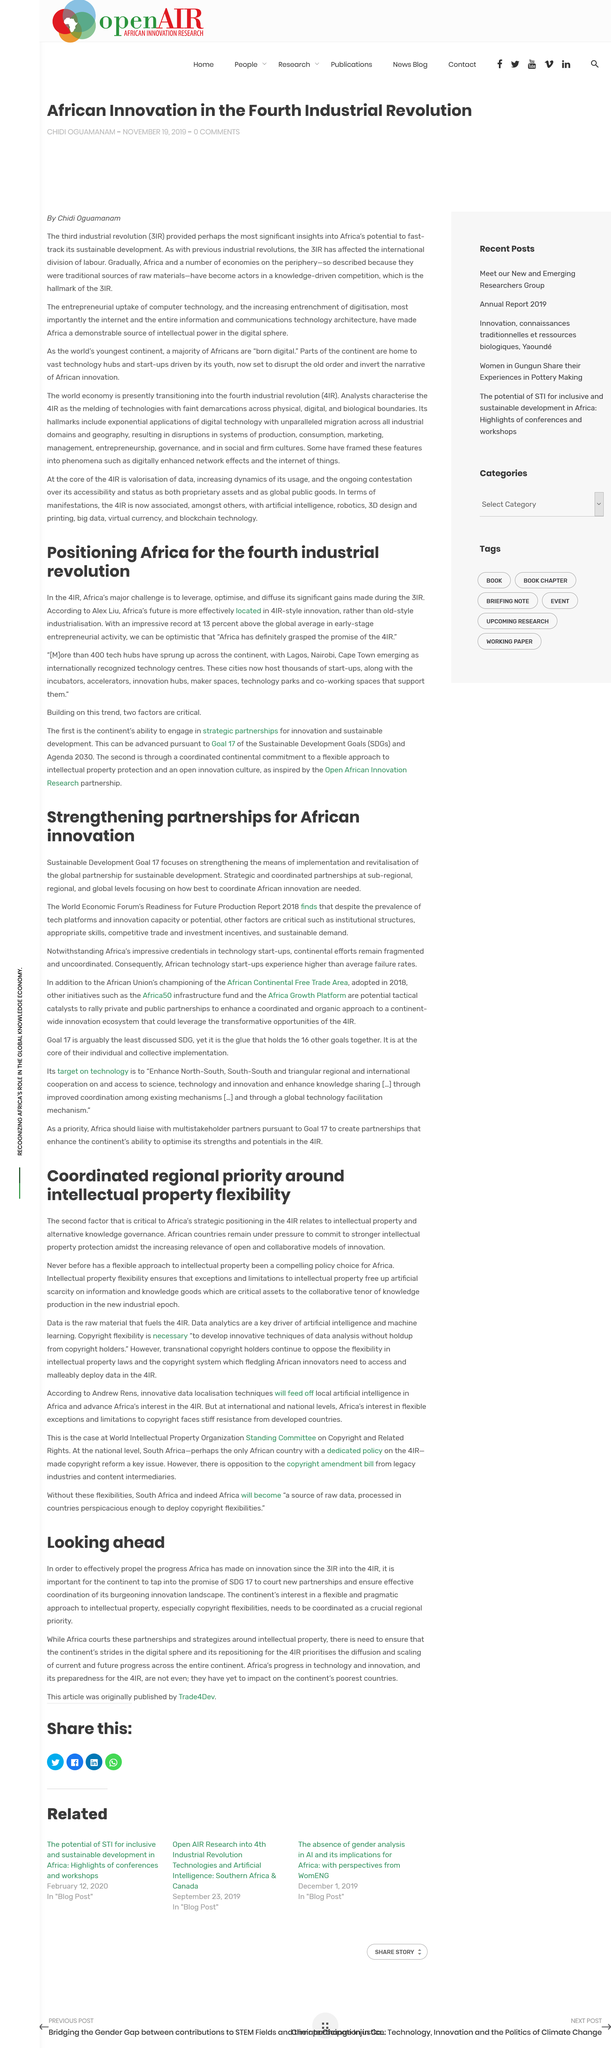Indicate a few pertinent items in this graphic. Africa's strategic positioning in the 4th Industrial Revolution depends criticaly on intellectual property and alternative knowledge governance. Strengthening partnerships for African innovation requires critical factors such as institutional structures, appropriate skills, competitive trade and investment incentives, and sustainable demand. African countries are under pressure to commit to stronger intellectual property protection in light of the growing importance of open and collaborative models of innovation. Intellectual property flexibility ensures that exceptions and limitations to intellectual property are in place, freeing up artificial scarcity on information and knowledge goods, which are critical assets to the collaborative nature of knowledge production in the new industrial epoch. In excess of 400 technology hubs have emerged across the continent. 